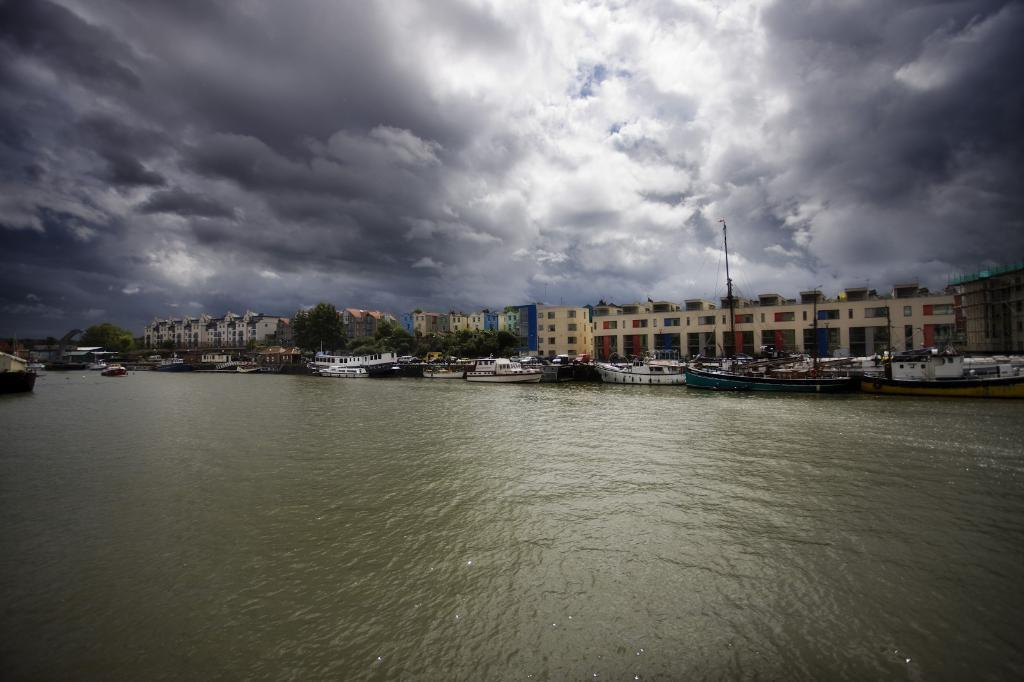What is in the water in the image? There are boats in the water. What can be seen in the background of the image? There are trees, poles, and buildings in the background. How would you describe the sky in the image? The sky is cloudy. What type of cork can be seen floating in the water near the boats? There is no cork present in the image; it only features boats in the water, trees, poles, buildings, and a cloudy sky in the background. 